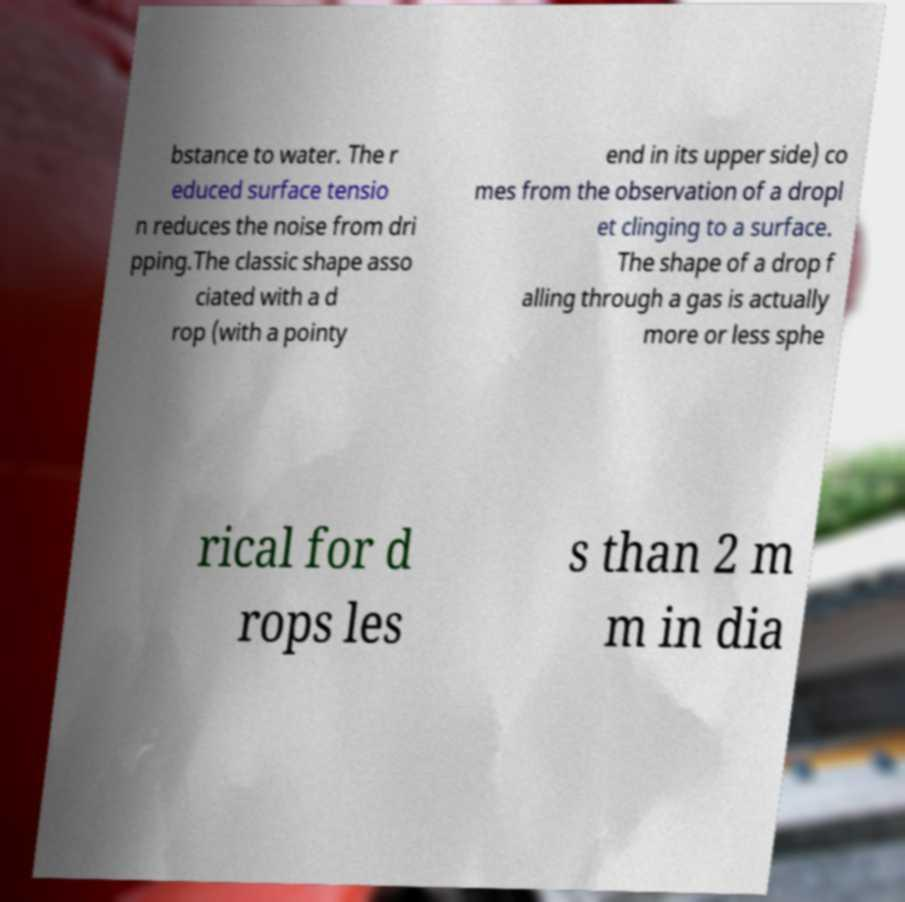Please read and relay the text visible in this image. What does it say? bstance to water. The r educed surface tensio n reduces the noise from dri pping.The classic shape asso ciated with a d rop (with a pointy end in its upper side) co mes from the observation of a dropl et clinging to a surface. The shape of a drop f alling through a gas is actually more or less sphe rical for d rops les s than 2 m m in dia 